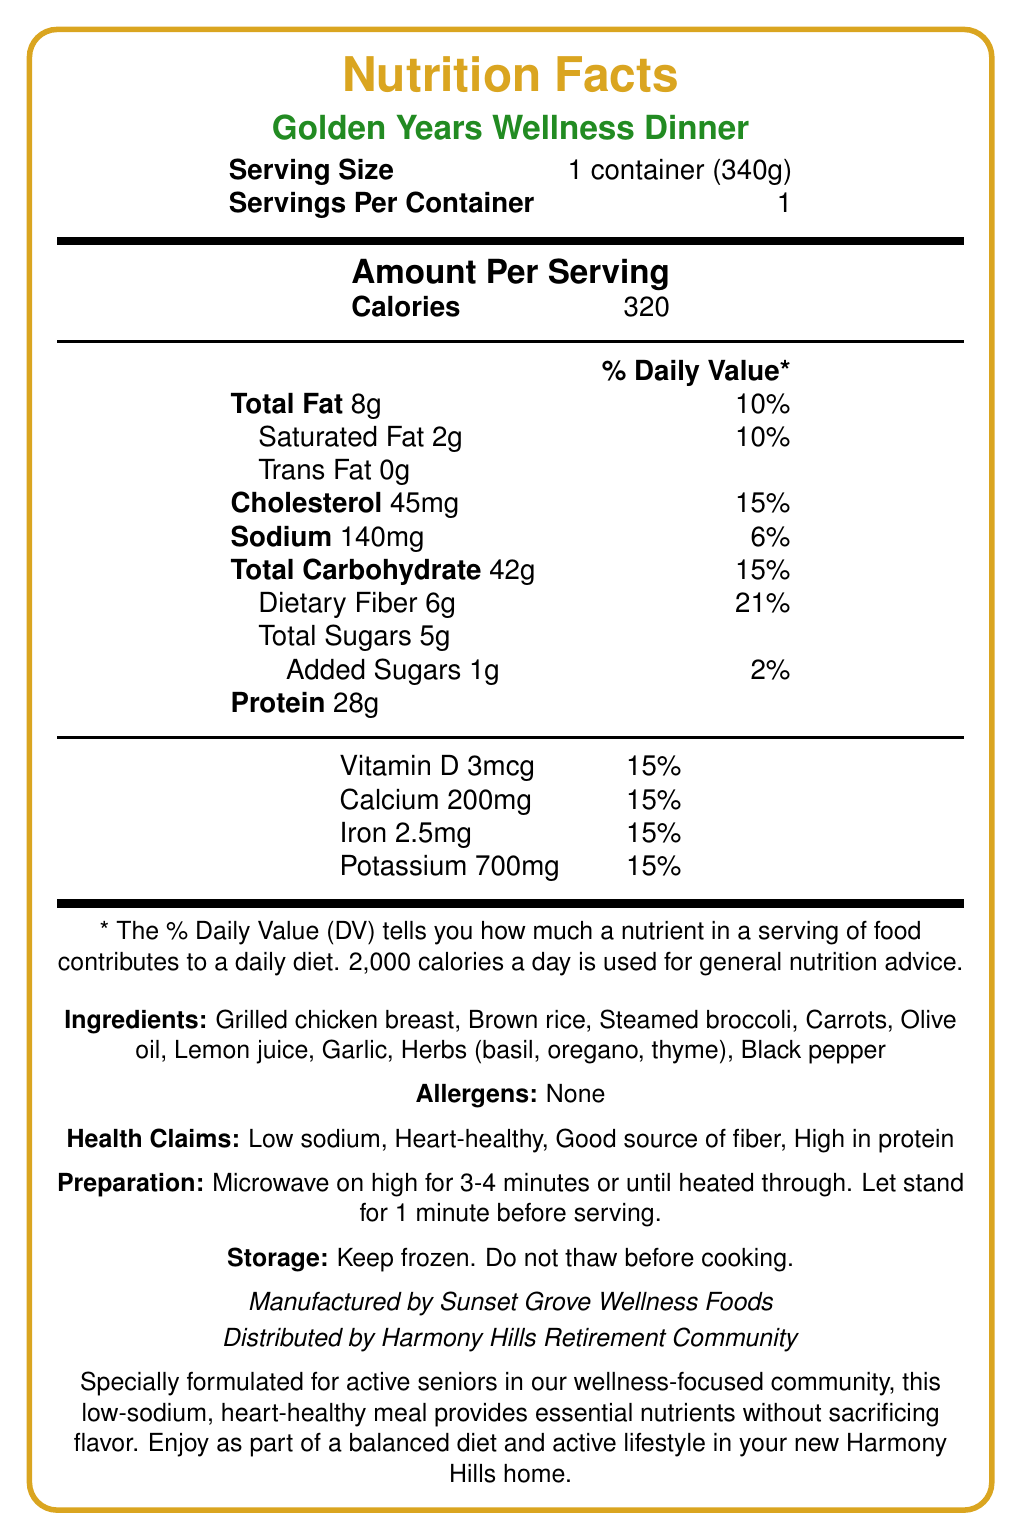what is the serving size of the Golden Years Wellness Dinner? The serving size is clearly mentioned as "1 container (340g)" in the document.
Answer: 1 container (340g) How many calories are in one serving of the Golden Years Wellness Dinner? The document states that the amount per serving is 320 calories.
Answer: 320 What percentage of the daily value for sodium does this dinner provide? The document lists sodium at 140mg per serving, which is 6% of the daily value.
Answer: 6% What are the primary ingredients in the Golden Years Wellness Dinner? The ingredients are listed under the "Ingredients" section.
Answer: Grilled chicken breast, Brown rice, Steamed broccoli, Carrots, Olive oil, Lemon juice, Garlic, Herbs (basil, oregano, thyme), Black pepper How much dietary fiber is in this meal, and what percentage of the daily value does it offer? The meal contains 6g of dietary fiber, which is 21% of the daily value.
Answer: 6g, 21% How many different herbs are listed in the ingredients? The document lists basil, oregano, and thyme as herbs.
Answer: 3 Which of the following health claims does the Golden Years Wellness Dinner not make? A. Good source of fiber B. High in protein C. Sugar-free D. Low sodium The health claims listed are low sodium, heart-healthy, good source of fiber, and high in protein; sugar-free is not listed.
Answer: C. Sugar-free What is the amount of protein in the Golden Years Wellness Dinner? A. 20g B. 25g C. 28g D. 30g The protein content is listed as 28g.
Answer: C. 28g Is this product suitable for someone with dietary restrictions related to allergens? The document states that there are no allergens in this product.
Answer: Yes Does the Golden Years Wellness Dinner require refrigeration after opening? The document only includes storage instructions to keep it frozen and does not mention storage after opening.
Answer: Not enough information Summarize the main idea of this document. The document covers all essential aspects of the product, including nutritional values, ingredients, and preparation instructions, emphasizing that it is tailored for active seniors aiming for a healthy lifestyle.
Answer: The document provides the nutrition facts for the Golden Years Wellness Dinner, a low-sodium, heart-healthy frozen meal designed for active seniors in a wellness-focused community. It includes detailed nutritional information, ingredients, allergens, preparation, and storage instructions, along with health claims and manufacturer details. 